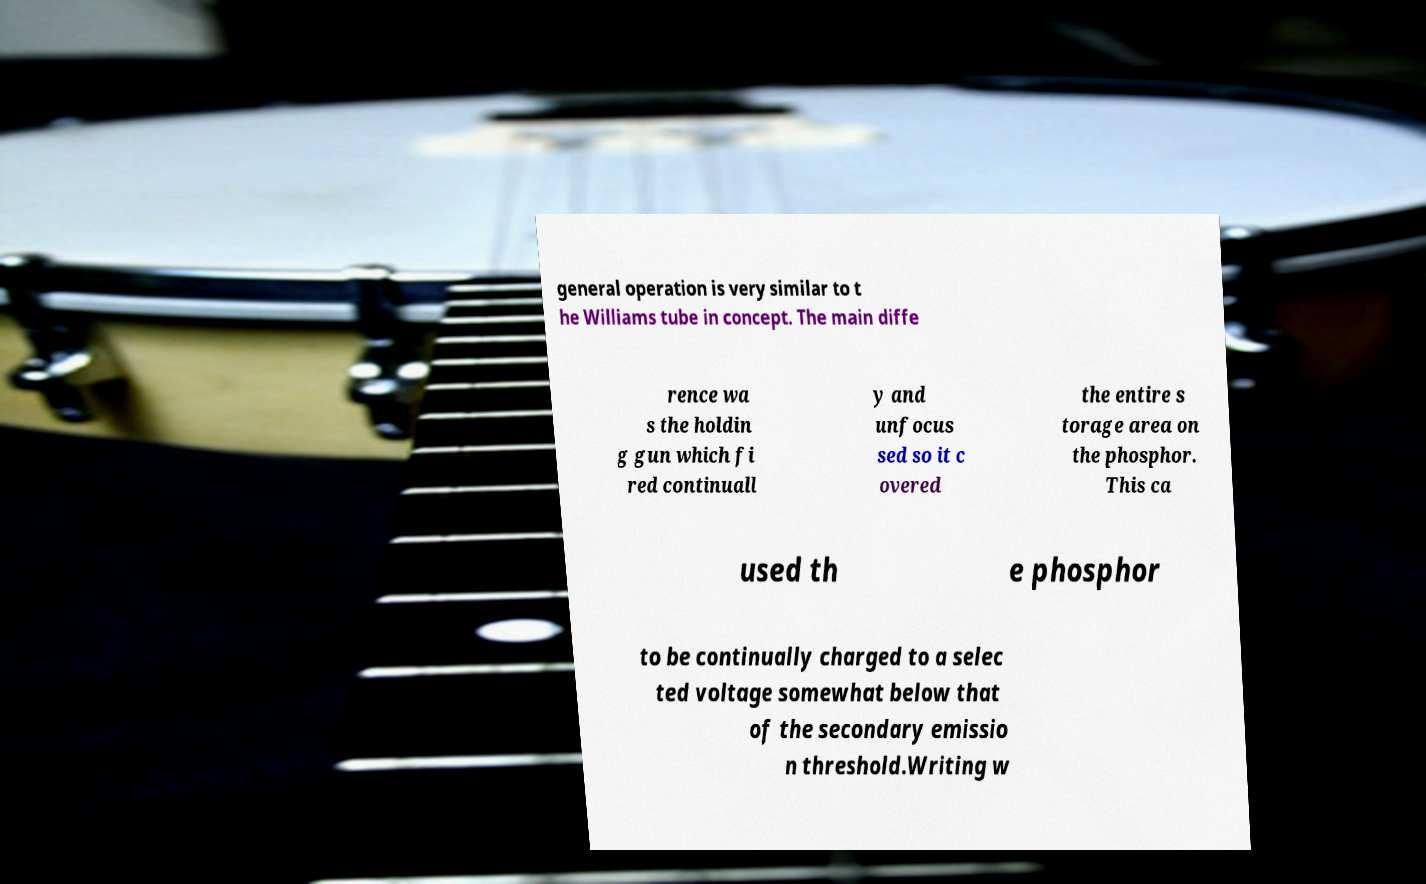Please read and relay the text visible in this image. What does it say? general operation is very similar to t he Williams tube in concept. The main diffe rence wa s the holdin g gun which fi red continuall y and unfocus sed so it c overed the entire s torage area on the phosphor. This ca used th e phosphor to be continually charged to a selec ted voltage somewhat below that of the secondary emissio n threshold.Writing w 